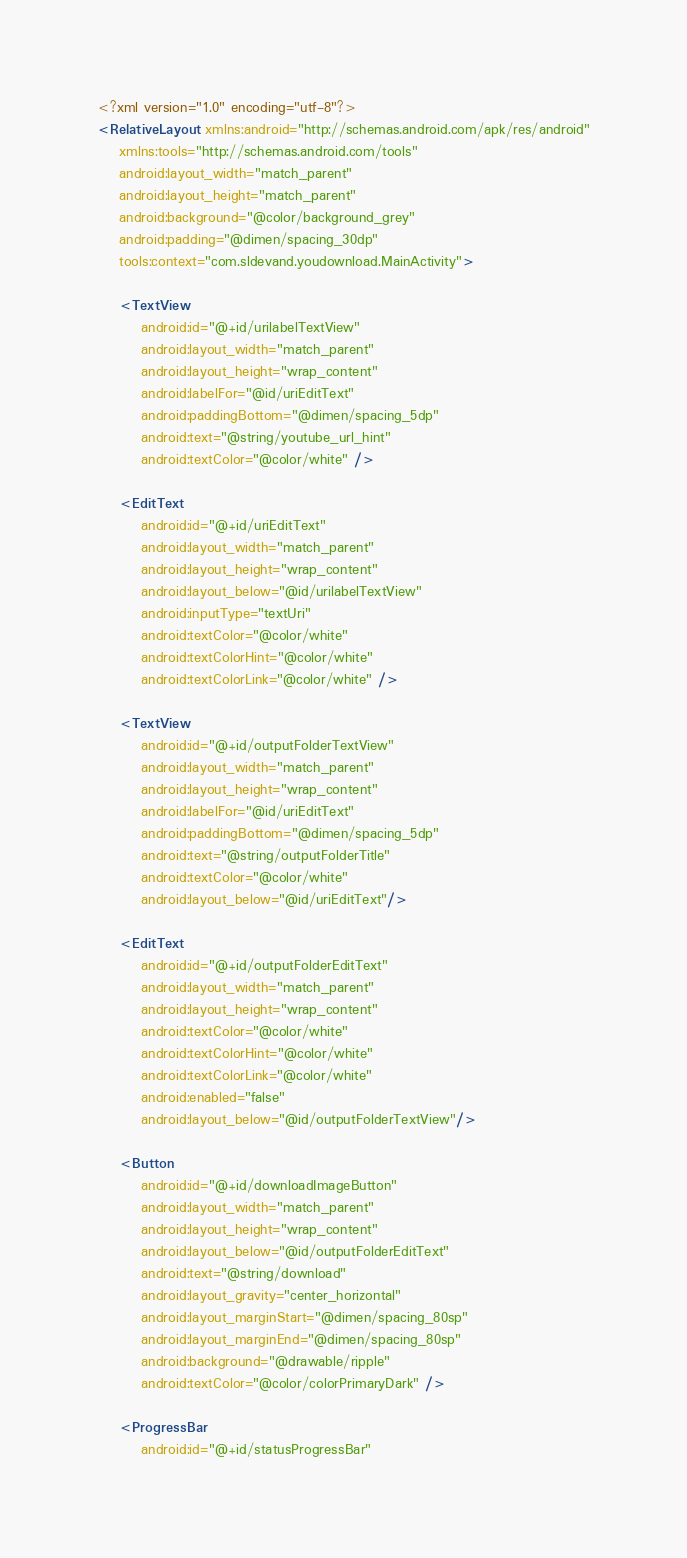Convert code to text. <code><loc_0><loc_0><loc_500><loc_500><_XML_><?xml version="1.0" encoding="utf-8"?>
<RelativeLayout xmlns:android="http://schemas.android.com/apk/res/android"
    xmlns:tools="http://schemas.android.com/tools"
    android:layout_width="match_parent"
    android:layout_height="match_parent"
    android:background="@color/background_grey"
    android:padding="@dimen/spacing_30dp"
    tools:context="com.sldevand.youdownload.MainActivity">

    <TextView
        android:id="@+id/urilabelTextView"
        android:layout_width="match_parent"
        android:layout_height="wrap_content"
        android:labelFor="@id/uriEditText"
        android:paddingBottom="@dimen/spacing_5dp"
        android:text="@string/youtube_url_hint"
        android:textColor="@color/white" />

    <EditText
        android:id="@+id/uriEditText"
        android:layout_width="match_parent"
        android:layout_height="wrap_content"
        android:layout_below="@id/urilabelTextView"
        android:inputType="textUri"
        android:textColor="@color/white"
        android:textColorHint="@color/white"
        android:textColorLink="@color/white" />

    <TextView
        android:id="@+id/outputFolderTextView"
        android:layout_width="match_parent"
        android:layout_height="wrap_content"
        android:labelFor="@id/uriEditText"
        android:paddingBottom="@dimen/spacing_5dp"
        android:text="@string/outputFolderTitle"
        android:textColor="@color/white"
        android:layout_below="@id/uriEditText"/>

    <EditText
        android:id="@+id/outputFolderEditText"
        android:layout_width="match_parent"
        android:layout_height="wrap_content"
        android:textColor="@color/white"
        android:textColorHint="@color/white"
        android:textColorLink="@color/white"
        android:enabled="false"
        android:layout_below="@id/outputFolderTextView"/>

    <Button
        android:id="@+id/downloadImageButton"
        android:layout_width="match_parent"
        android:layout_height="wrap_content"
        android:layout_below="@id/outputFolderEditText"
        android:text="@string/download"
        android:layout_gravity="center_horizontal"
        android:layout_marginStart="@dimen/spacing_80sp"
        android:layout_marginEnd="@dimen/spacing_80sp"
        android:background="@drawable/ripple"
        android:textColor="@color/colorPrimaryDark" />

    <ProgressBar
        android:id="@+id/statusProgressBar"</code> 